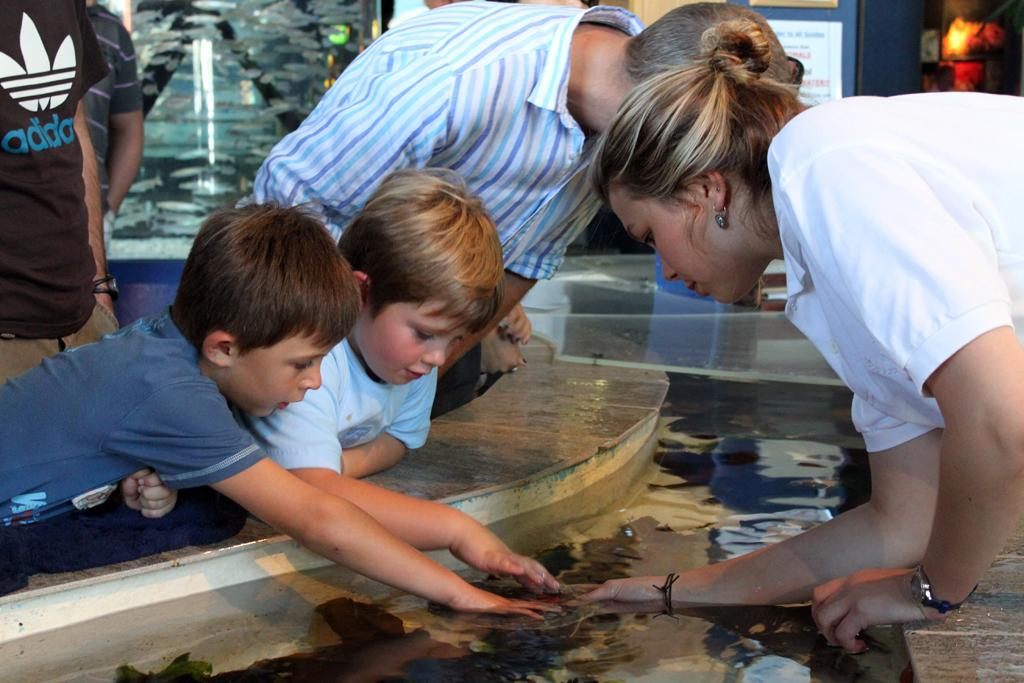What can be seen in the foreground of the image? There are people and water in the foreground of the image. What type of structure might be visible in the background of the image? It appears to be a glass door in the background of the image. What decorative elements can be seen in the background of the image? There are posters in the background of the image. What type of riddle is written on the glass door in the image? There is no riddle written on the glass door in the image; it is a glass door without any text or riddle. What form does the grip of the poster take in the image? There is no grip mentioned or visible in the image; it is about posters on a glass door. 